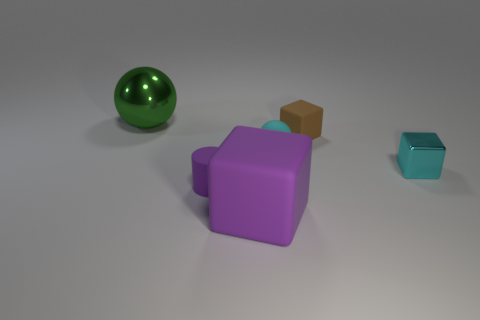How many things are either small cyan shiny objects or big purple cubes?
Your response must be concise. 2. There is a purple thing that is behind the large matte block; does it have the same size as the sphere in front of the green metallic thing?
Your answer should be very brief. Yes. How many other objects are there of the same size as the brown thing?
Provide a short and direct response. 3. How many objects are either tiny matte cylinders that are left of the brown matte object or things behind the cylinder?
Offer a very short reply. 5. Are the small brown block and the thing that is left of the small matte cylinder made of the same material?
Provide a short and direct response. No. How many other objects are there of the same shape as the large metallic thing?
Provide a short and direct response. 1. The block that is behind the small cyan object that is behind the shiny thing to the right of the tiny brown thing is made of what material?
Provide a succinct answer. Rubber. Are there an equal number of cyan metal blocks behind the rubber ball and blue shiny things?
Ensure brevity in your answer.  Yes. Do the large thing in front of the tiny matte cylinder and the small block that is in front of the tiny cyan sphere have the same material?
Give a very brief answer. No. There is a cyan thing that is to the left of the small shiny object; does it have the same shape as the metallic object left of the brown rubber cube?
Offer a very short reply. Yes. 